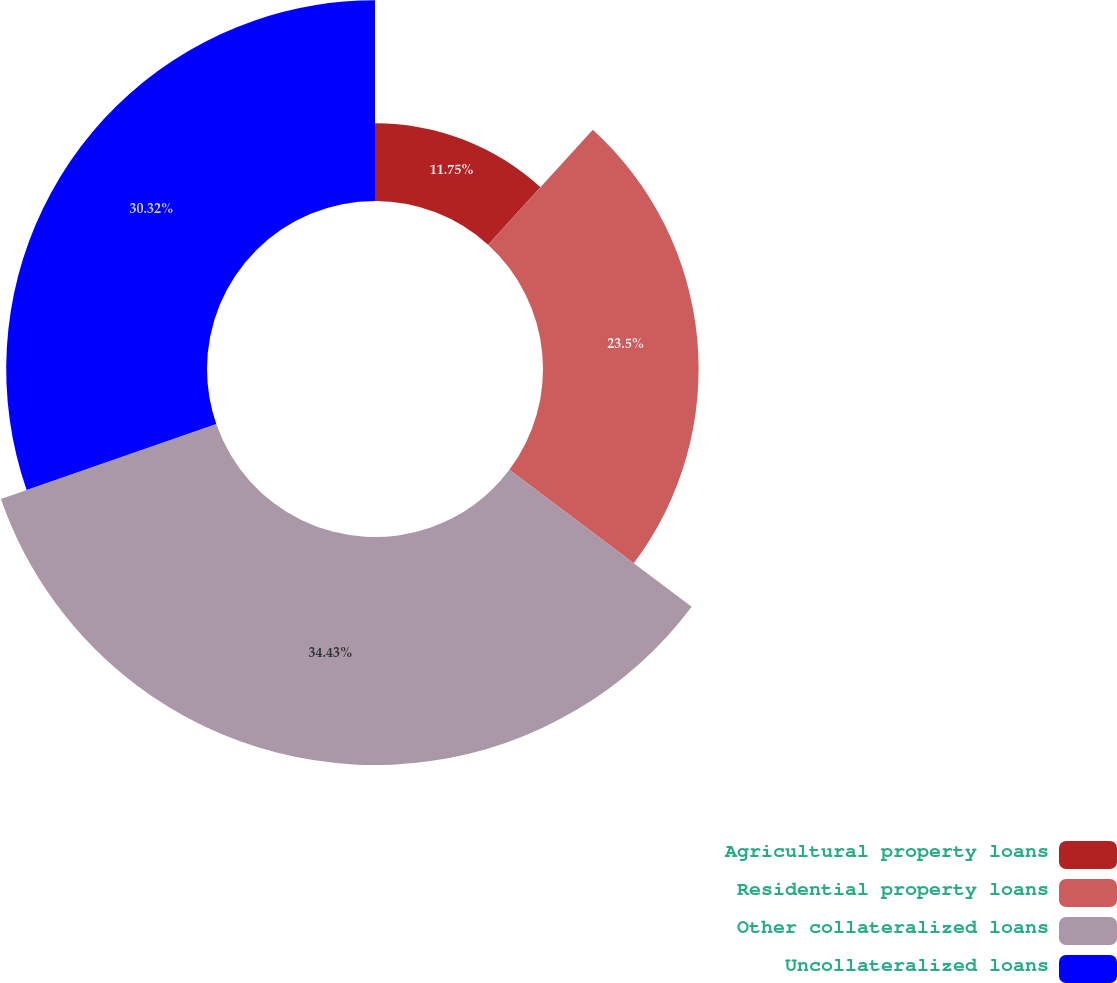Convert chart to OTSL. <chart><loc_0><loc_0><loc_500><loc_500><pie_chart><fcel>Agricultural property loans<fcel>Residential property loans<fcel>Other collateralized loans<fcel>Uncollateralized loans<nl><fcel>11.75%<fcel>23.5%<fcel>34.43%<fcel>30.32%<nl></chart> 